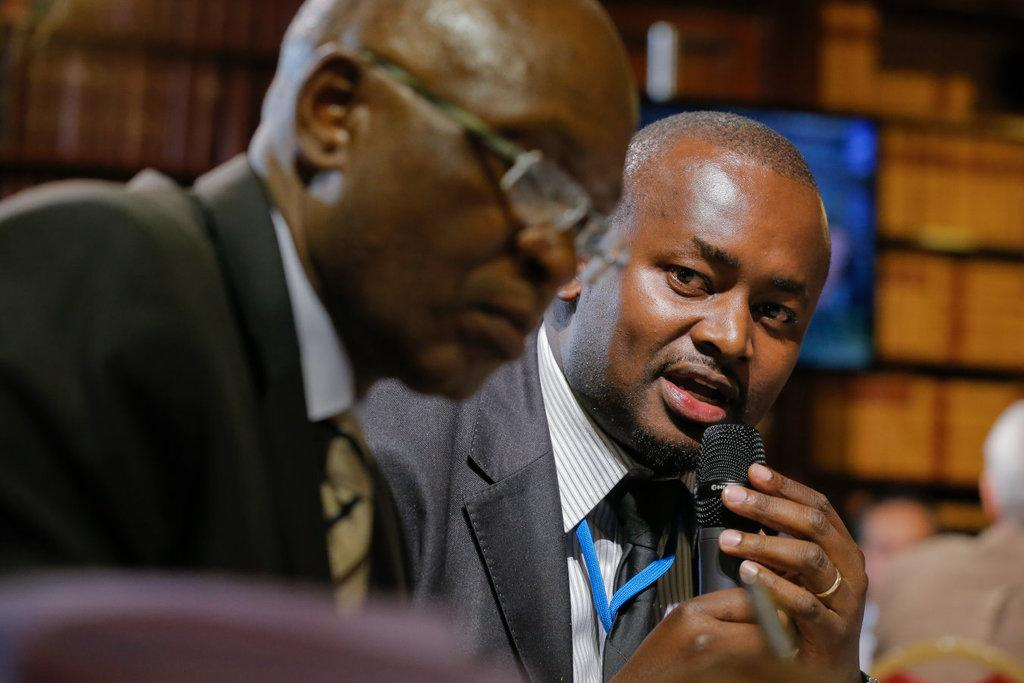How many people are present in the image? There are two men in the image. What is one of the men holding? One of the men is holding a microphone. What is the man with the microphone doing? The man with the microphone is speaking. Can you describe the people in the background of the image? There are people sitting on chairs in the background of the image. What type of sugar is being used by the man with the microphone? There is no sugar present in the image, and the man with the microphone is not using any sugar. How does the clam feel about the man with the microphone? There are no clams present in the image, so it is not possible to determine how a clam might feel about the man with the microphone. 